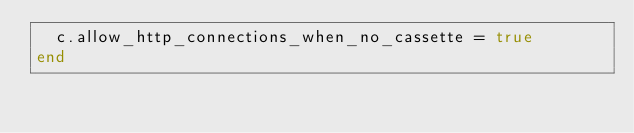Convert code to text. <code><loc_0><loc_0><loc_500><loc_500><_Ruby_>  c.allow_http_connections_when_no_cassette = true
end
</code> 